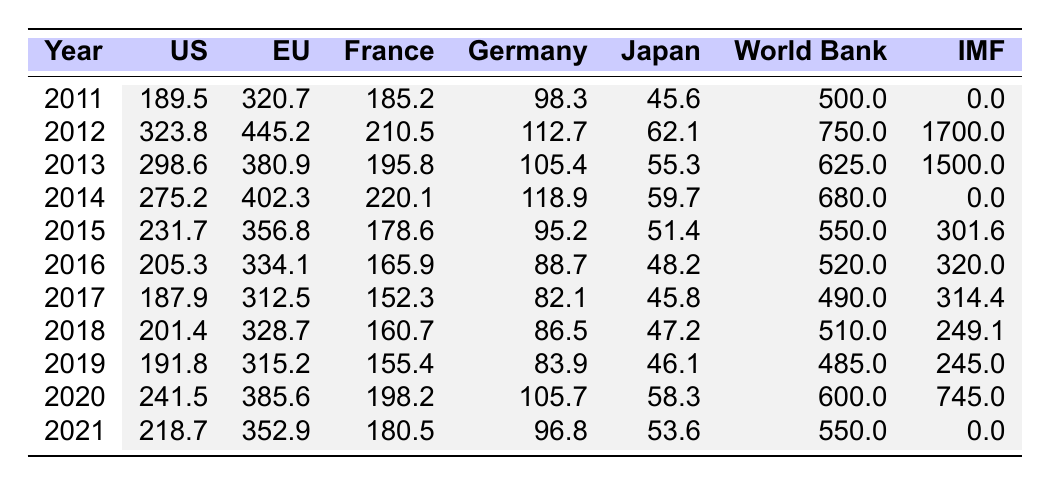What was the highest amount of foreign aid received by Tunisia in 2012? In 2012, Tunisia received $750 million from the World Bank, which is the highest amount compared to other years.
Answer: 750 million Which donor provided the least amount of foreign aid to Tunisia in 2021? In 2021, the IMF provided $0 million in aid, which is the least among all donors.
Answer: IMF What was the total foreign aid received by Tunisia from the European Union from 2011 to 2021? Summing the amounts from the EU for each year: 320.7 + 445.2 + 380.9 + 402.3 + 356.8 + 334.1 + 312.5 + 328.7 + 315.2 + 385.6 + 352.9 = 4,263.8 million dollars.
Answer: 4263.8 million Did the total foreign aid from the World Bank increase from 2011 to 2021? Comparing the values, it is clear that the World Bank aid decreased from $500 million in 2011 to $550 million in 2021. Therefore, it did not increase.
Answer: No What was the average foreign aid received by Tunisia from Germany between 2011 and 2021? The total aid from Germany is 98.3 + 112.7 + 105.4 + 118.9 + 95.2 + 88.7 + 82.1 + 86.5 + 83.9 + 105.7 + 96.8 = 1,153.1 million dollars. Dividing this by 11 years gives an average of 105.83 million dollars.
Answer: 105.83 million In how many years did foreign aid from Japan exceed 50 million dollars? From the data, Japan provided more than 50 million dollars in 2012, 2013, 2014, and 2020; thus, this occurred in 4 years.
Answer: 4 years Which donor's aid was consistently decreasing from 2011 to 2017? Observing the data, the amounts provided by the United States showed a consistent decrease from $189.5 million in 2011 to $187.9 million in 2017.
Answer: United States What was the trend in foreign aid received from France from 2011 to 2021? Reviewing the data, the aid from France generally fluctuated but showed a peak in 2014 ($220.1 million) and then tended to decrease towards 2021.
Answer: Fluctuated with a downward trend after 2014 